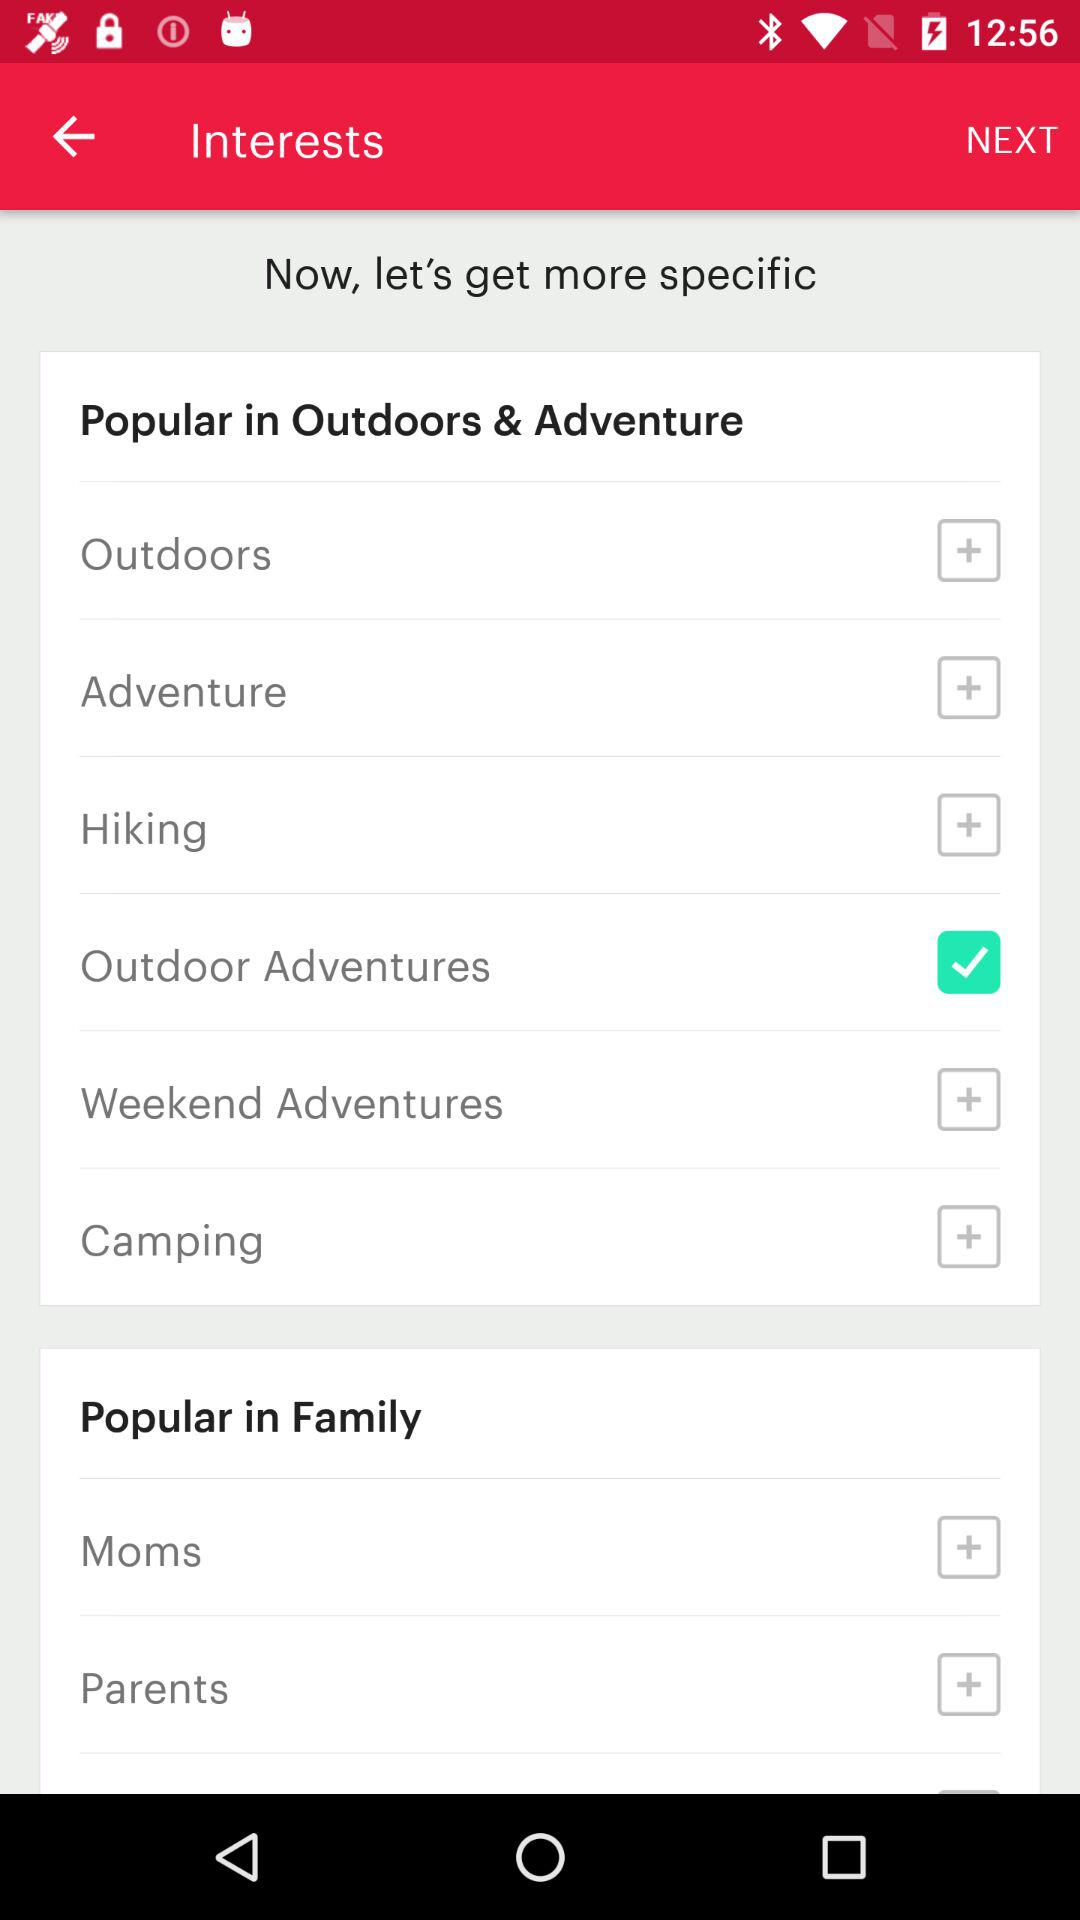Which option is selected? The selected option is "Outdoor Adventures". 